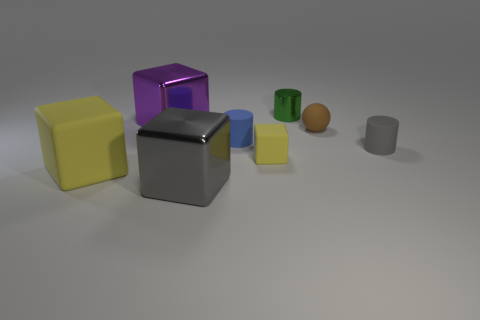Subtract 1 cubes. How many cubes are left? 3 Add 2 purple metal objects. How many objects exist? 10 Subtract all cylinders. How many objects are left? 5 Add 4 large cyan balls. How many large cyan balls exist? 4 Subtract 0 green cubes. How many objects are left? 8 Subtract all big gray shiny cubes. Subtract all small green metal things. How many objects are left? 6 Add 6 rubber balls. How many rubber balls are left? 7 